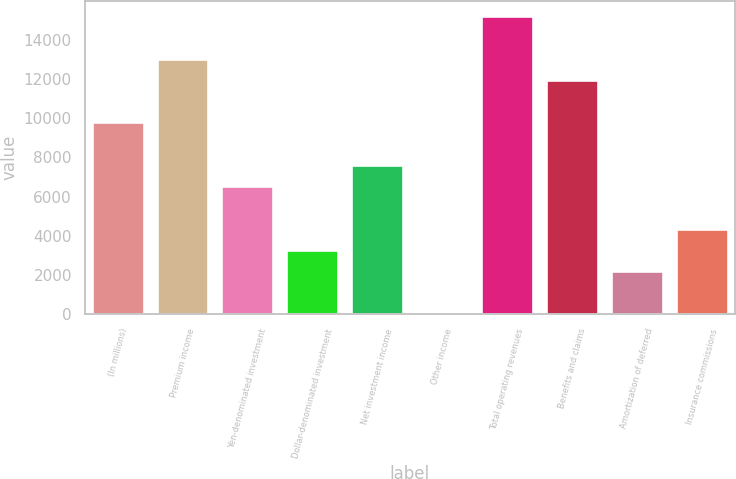<chart> <loc_0><loc_0><loc_500><loc_500><bar_chart><fcel>(In millions)<fcel>Premium income<fcel>Yen-denominated investment<fcel>Dollar-denominated investment<fcel>Net investment income<fcel>Other income<fcel>Total operating revenues<fcel>Benefits and claims<fcel>Amortization of deferred<fcel>Insurance commissions<nl><fcel>9781.2<fcel>13032.6<fcel>6529.8<fcel>3278.4<fcel>7613.6<fcel>27<fcel>15200.2<fcel>11948.8<fcel>2194.6<fcel>4362.2<nl></chart> 